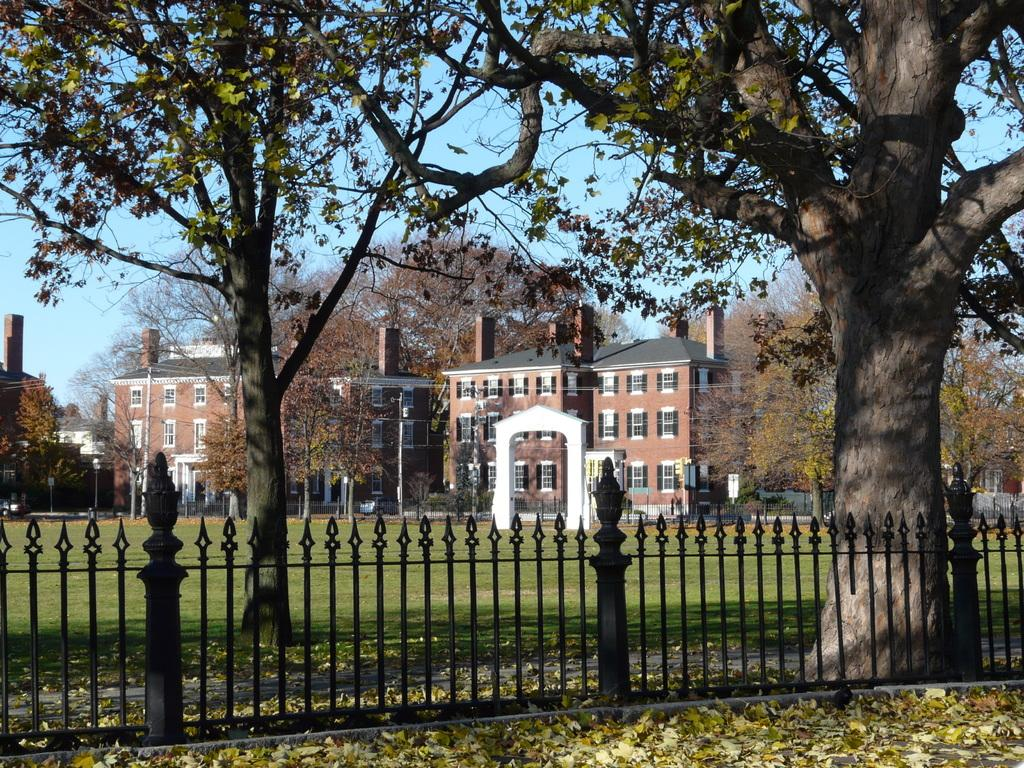What type of structure can be seen in the image? There is fencing in the image. What natural elements are present in the image? There are trees in the image. What can be seen beneath the fencing and trees? The ground is visible in the image. What type of buildings can be seen in the image? There are houses in the image. Is there an umbrella being used by someone in the image? There is no umbrella present in the image. Can you see any waves in the image? There are no waves visible in the image, as it features fencing, trees, the ground, and houses. 